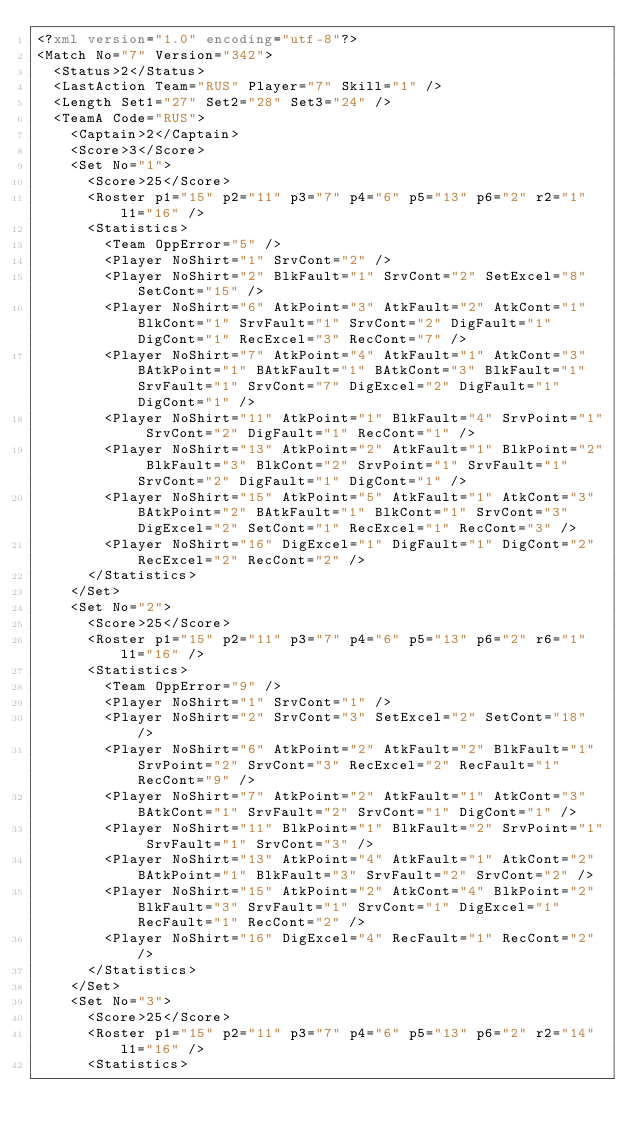Convert code to text. <code><loc_0><loc_0><loc_500><loc_500><_XML_><?xml version="1.0" encoding="utf-8"?>
<Match No="7" Version="342">
  <Status>2</Status>
  <LastAction Team="RUS" Player="7" Skill="1" />
  <Length Set1="27" Set2="28" Set3="24" />
  <TeamA Code="RUS">
    <Captain>2</Captain>
    <Score>3</Score>
    <Set No="1">
      <Score>25</Score>
      <Roster p1="15" p2="11" p3="7" p4="6" p5="13" p6="2" r2="1" l1="16" />
      <Statistics>
        <Team OppError="5" />
        <Player NoShirt="1" SrvCont="2" />
        <Player NoShirt="2" BlkFault="1" SrvCont="2" SetExcel="8" SetCont="15" />
        <Player NoShirt="6" AtkPoint="3" AtkFault="2" AtkCont="1" BlkCont="1" SrvFault="1" SrvCont="2" DigFault="1" DigCont="1" RecExcel="3" RecCont="7" />
        <Player NoShirt="7" AtkPoint="4" AtkFault="1" AtkCont="3" BAtkPoint="1" BAtkFault="1" BAtkCont="3" BlkFault="1" SrvFault="1" SrvCont="7" DigExcel="2" DigFault="1" DigCont="1" />
        <Player NoShirt="11" AtkPoint="1" BlkFault="4" SrvPoint="1" SrvCont="2" DigFault="1" RecCont="1" />
        <Player NoShirt="13" AtkPoint="2" AtkFault="1" BlkPoint="2" BlkFault="3" BlkCont="2" SrvPoint="1" SrvFault="1" SrvCont="2" DigFault="1" DigCont="1" />
        <Player NoShirt="15" AtkPoint="5" AtkFault="1" AtkCont="3" BAtkPoint="2" BAtkFault="1" BlkCont="1" SrvCont="3" DigExcel="2" SetCont="1" RecExcel="1" RecCont="3" />
        <Player NoShirt="16" DigExcel="1" DigFault="1" DigCont="2" RecExcel="2" RecCont="2" />
      </Statistics>
    </Set>
    <Set No="2">
      <Score>25</Score>
      <Roster p1="15" p2="11" p3="7" p4="6" p5="13" p6="2" r6="1" l1="16" />
      <Statistics>
        <Team OppError="9" />
        <Player NoShirt="1" SrvCont="1" />
        <Player NoShirt="2" SrvCont="3" SetExcel="2" SetCont="18" />
        <Player NoShirt="6" AtkPoint="2" AtkFault="2" BlkFault="1" SrvPoint="2" SrvCont="3" RecExcel="2" RecFault="1" RecCont="9" />
        <Player NoShirt="7" AtkPoint="2" AtkFault="1" AtkCont="3" BAtkCont="1" SrvFault="2" SrvCont="1" DigCont="1" />
        <Player NoShirt="11" BlkPoint="1" BlkFault="2" SrvPoint="1" SrvFault="1" SrvCont="3" />
        <Player NoShirt="13" AtkPoint="4" AtkFault="1" AtkCont="2" BAtkPoint="1" BlkFault="3" SrvFault="2" SrvCont="2" />
        <Player NoShirt="15" AtkPoint="2" AtkCont="4" BlkPoint="2" BlkFault="3" SrvFault="1" SrvCont="1" DigExcel="1" RecFault="1" RecCont="2" />
        <Player NoShirt="16" DigExcel="4" RecFault="1" RecCont="2" />
      </Statistics>
    </Set>
    <Set No="3">
      <Score>25</Score>
      <Roster p1="15" p2="11" p3="7" p4="6" p5="13" p6="2" r2="14" l1="16" />
      <Statistics></code> 